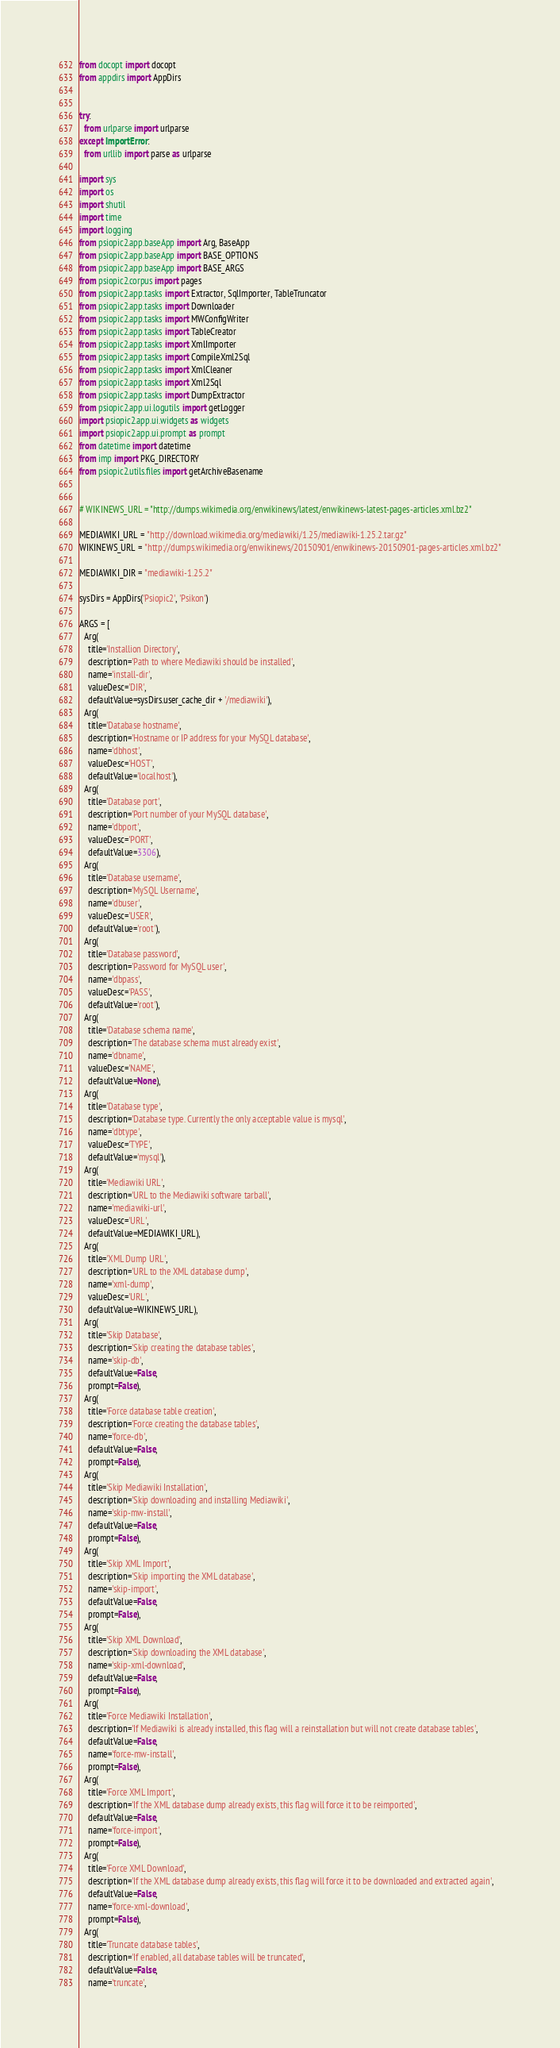<code> <loc_0><loc_0><loc_500><loc_500><_Python_>from docopt import docopt
from appdirs import AppDirs


try:
  from urlparse import urlparse
except ImportError:
  from urllib import parse as urlparse

import sys
import os
import shutil
import time
import logging
from psiopic2.app.baseApp import Arg, BaseApp
from psiopic2.app.baseApp import BASE_OPTIONS
from psiopic2.app.baseApp import BASE_ARGS
from psiopic2.corpus import pages
from psiopic2.app.tasks import Extractor, SqlImporter, TableTruncator
from psiopic2.app.tasks import Downloader
from psiopic2.app.tasks import MWConfigWriter
from psiopic2.app.tasks import TableCreator
from psiopic2.app.tasks import XmlImporter
from psiopic2.app.tasks import CompileXml2Sql
from psiopic2.app.tasks import XmlCleaner
from psiopic2.app.tasks import Xml2Sql
from psiopic2.app.tasks import DumpExtractor
from psiopic2.app.ui.logutils import getLogger
import psiopic2.app.ui.widgets as widgets
import psiopic2.app.ui.prompt as prompt
from datetime import datetime
from imp import PKG_DIRECTORY
from psiopic2.utils.files import getArchiveBasename


# WIKINEWS_URL = "http://dumps.wikimedia.org/enwikinews/latest/enwikinews-latest-pages-articles.xml.bz2"

MEDIAWIKI_URL = "http://download.wikimedia.org/mediawiki/1.25/mediawiki-1.25.2.tar.gz"
WIKINEWS_URL = "http://dumps.wikimedia.org/enwikinews/20150901/enwikinews-20150901-pages-articles.xml.bz2"

MEDIAWIKI_DIR = "mediawiki-1.25.2"

sysDirs = AppDirs('Psiopic2', 'Psikon')

ARGS = [
  Arg(
    title='Installion Directory', 
    description='Path to where Mediawiki should be installed',
    name='install-dir',
    valueDesc='DIR',
    defaultValue=sysDirs.user_cache_dir + '/mediawiki'),
  Arg(
    title='Database hostname',
    description='Hostname or IP address for your MySQL database',
    name='dbhost',
    valueDesc='HOST',
    defaultValue='localhost'),
  Arg(
    title='Database port',
    description='Port number of your MySQL database',
    name='dbport',
    valueDesc='PORT',
    defaultValue=3306),
  Arg(
    title='Database username',
    description='MySQL Username',
    name='dbuser',
    valueDesc='USER',
    defaultValue='root'),
  Arg(
    title='Database password',
    description='Password for MySQL user',
    name='dbpass',
    valueDesc='PASS',
    defaultValue='root'),
  Arg(
    title='Database schema name',
    description='The database schema must already exist',
    name='dbname',
    valueDesc='NAME',
    defaultValue=None),
  Arg(
    title='Database type',
    description='Database type. Currently the only acceptable value is mysql',
    name='dbtype',
    valueDesc='TYPE',
    defaultValue='mysql'),
  Arg(
    title='Mediawiki URL',
    description='URL to the Mediawiki software tarball',
    name='mediawiki-url',
    valueDesc='URL',
    defaultValue=MEDIAWIKI_URL),
  Arg(
    title='XML Dump URL',
    description='URL to the XML database dump',
    name='xml-dump',
    valueDesc='URL',
    defaultValue=WIKINEWS_URL),
  Arg(
    title='Skip Database',
    description='Skip creating the database tables',
    name='skip-db',
    defaultValue=False,
    prompt=False),
  Arg(
    title='Force database table creation',
    description='Force creating the database tables',
    name='force-db',
    defaultValue=False,
    prompt=False),
  Arg(
    title='Skip Mediawiki Installation',
    description='Skip downloading and installing Mediawiki',
    name='skip-mw-install',
    defaultValue=False,
    prompt=False),
  Arg(
    title='Skip XML Import',
    description='Skip importing the XML database',
    name='skip-import',
    defaultValue=False,
    prompt=False),
  Arg(
    title='Skip XML Download',
    description='Skip downloading the XML database',
    name='skip-xml-download',
    defaultValue=False,
    prompt=False),
  Arg(
    title='Force Mediawiki Installation',
    description='If Mediawiki is already installed, this flag will a reinstallation but will not create database tables',
    defaultValue=False,
    name='force-mw-install',
    prompt=False),
  Arg(
    title='Force XML Import',
    description='If the XML database dump already exists, this flag will force it to be reimported',
    defaultValue=False,
    name='force-import',
    prompt=False),
  Arg(
    title='Force XML Download',
    description='If the XML database dump already exists, this flag will force it to be downloaded and extracted again',
    defaultValue=False,
    name='force-xml-download',
    prompt=False),
  Arg(
    title='Truncate database tables',
    description='If enabled, all database tables will be truncated',
    defaultValue=False,
    name='truncate',</code> 